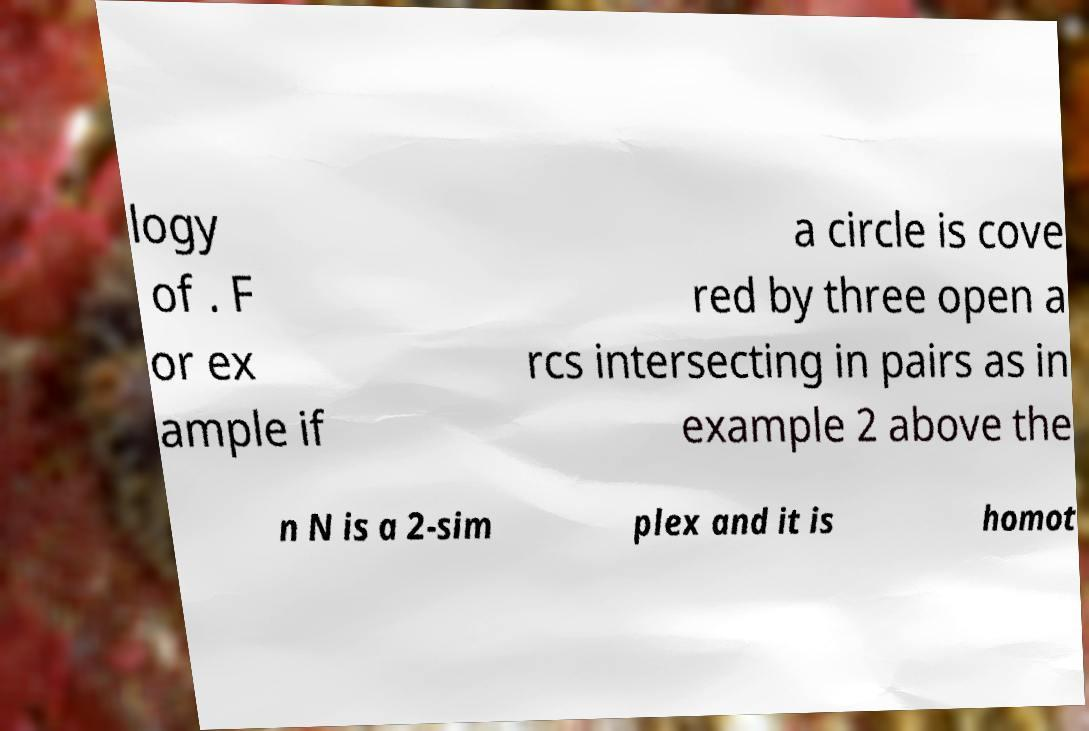Please identify and transcribe the text found in this image. logy of . F or ex ample if a circle is cove red by three open a rcs intersecting in pairs as in example 2 above the n N is a 2-sim plex and it is homot 